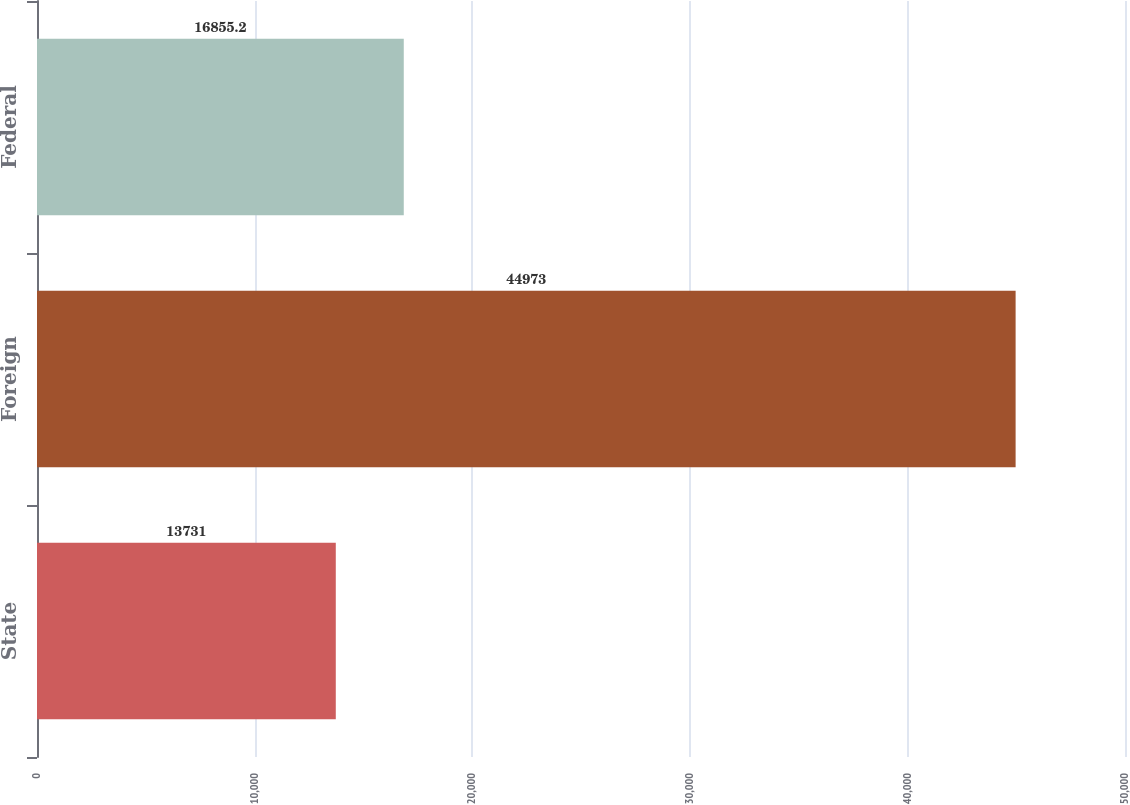Convert chart to OTSL. <chart><loc_0><loc_0><loc_500><loc_500><bar_chart><fcel>State<fcel>Foreign<fcel>Federal<nl><fcel>13731<fcel>44973<fcel>16855.2<nl></chart> 